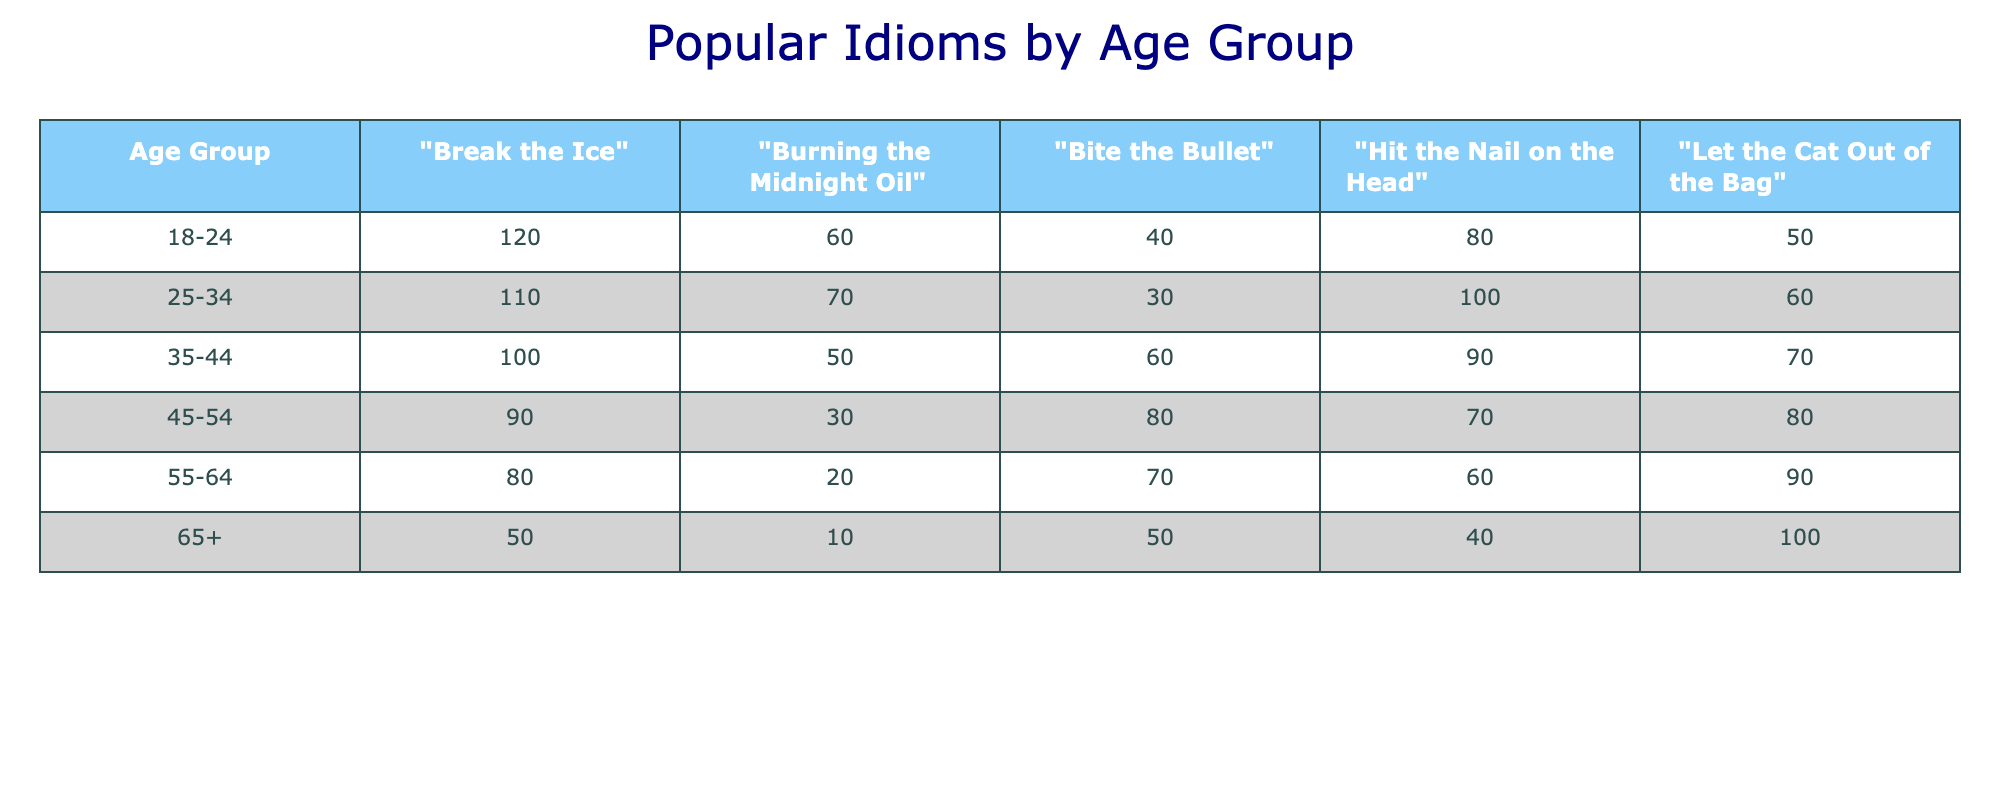What is the highest frequency of "Break the Ice" by age group? Looking at the table, "Break the Ice" shows the highest frequency in the 18-24 age group with a frequency of 120.
Answer: 120 Which idiom has the lowest frequency of use among the 65+ age group? In the 65+ age group, "Burning the Midnight Oil" has the lowest frequency with a count of 10.
Answer: 10 What is the total frequency of "Let the Cat Out of the Bag" across all age groups? The frequencies for "Let the Cat Out of the Bag" are 50, 60, 70, 80, 90, and 100 for the age groups respectively. Summing these values gives 50 + 60 + 70 + 80 + 90 + 100 = 450.
Answer: 450 Is "Bite the Bullet" used more frequently by younger individuals (18-34) as compared to older individuals (35+)? For younger individuals (18-34), the combined frequency for "Bite the Bullet" is 40 (18-24) + 30 (25-34) = 70. For older individuals (35+), the combined frequency is 60 (35-44) + 80 (45-54) + 70 (55-64) + 50 (65+) = 260. Since 70 is less than 260, the statement is false.
Answer: No What is the average frequency of "Hit the Nail on the Head" across all age groups? The frequencies for "Hit the Nail on the Head" are 80, 100, 90, 70, 60, and 40 for the age groups respectively. To find the average: (80 + 100 + 90 + 70 + 60 + 40) = 440. There are 6 age groups, so the average is 440/6 = 73.33.
Answer: 73.33 Which idiom is the most popular among people aged 45-54? Looking at the frequencies for the 45-54 age group, "Let the Cat Out of the Bag" has the highest frequency of 80 compared to the others.
Answer: Let the Cat Out of the Bag What is the difference in the frequency of "Burning the Midnight Oil" between the 25-34 and 55-64 age groups? For the 25-34 age group, "Burning the Midnight Oil" has a frequency of 70, while for the 55-64 age group, it is 20. The difference is 70 - 20 = 50.
Answer: 50 Are there more idioms used frequently by the 18-24 age group than the 65+ age group? Yes, the total frequency for the 18-24 age group is (120 + 60 + 40 + 80 + 50) = 350. For the 65+ age group, it is (50 + 10 + 50 + 40 + 100) = 250. Since 350 is greater than 250, the statement is true.
Answer: Yes 